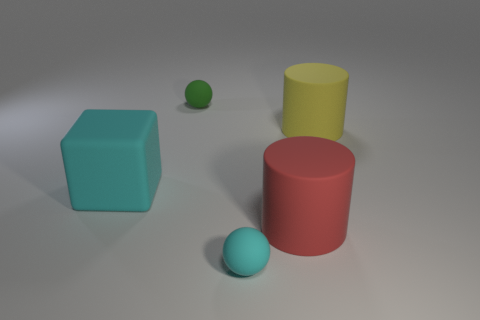What colors are the objects in the image? There are objects in blue, green, red, and yellow colors. Can you tell me how many objects are there of each color? Certainly, there is one blue cube, one green sphere, two red cylinders, and one yellow cylinder. 